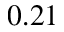Convert formula to latex. <formula><loc_0><loc_0><loc_500><loc_500>0 . 2 1</formula> 